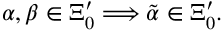Convert formula to latex. <formula><loc_0><loc_0><loc_500><loc_500>\alpha , \beta \in \Xi _ { 0 } ^ { \prime } \Longrightarrow \tilde { \alpha } \in \Xi _ { 0 } ^ { \prime } .</formula> 